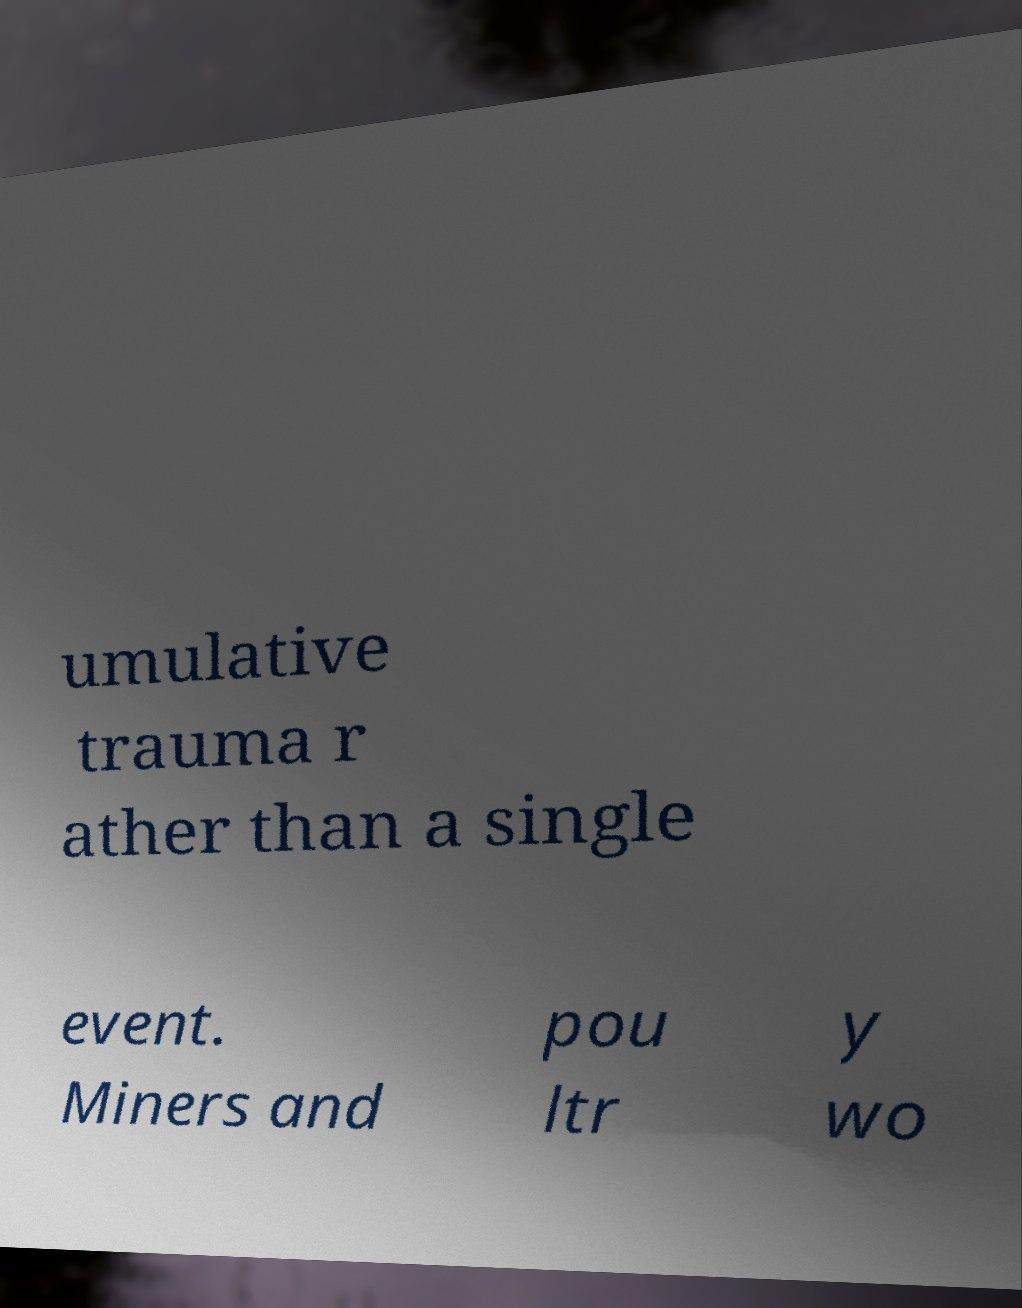Could you extract and type out the text from this image? umulative trauma r ather than a single event. Miners and pou ltr y wo 